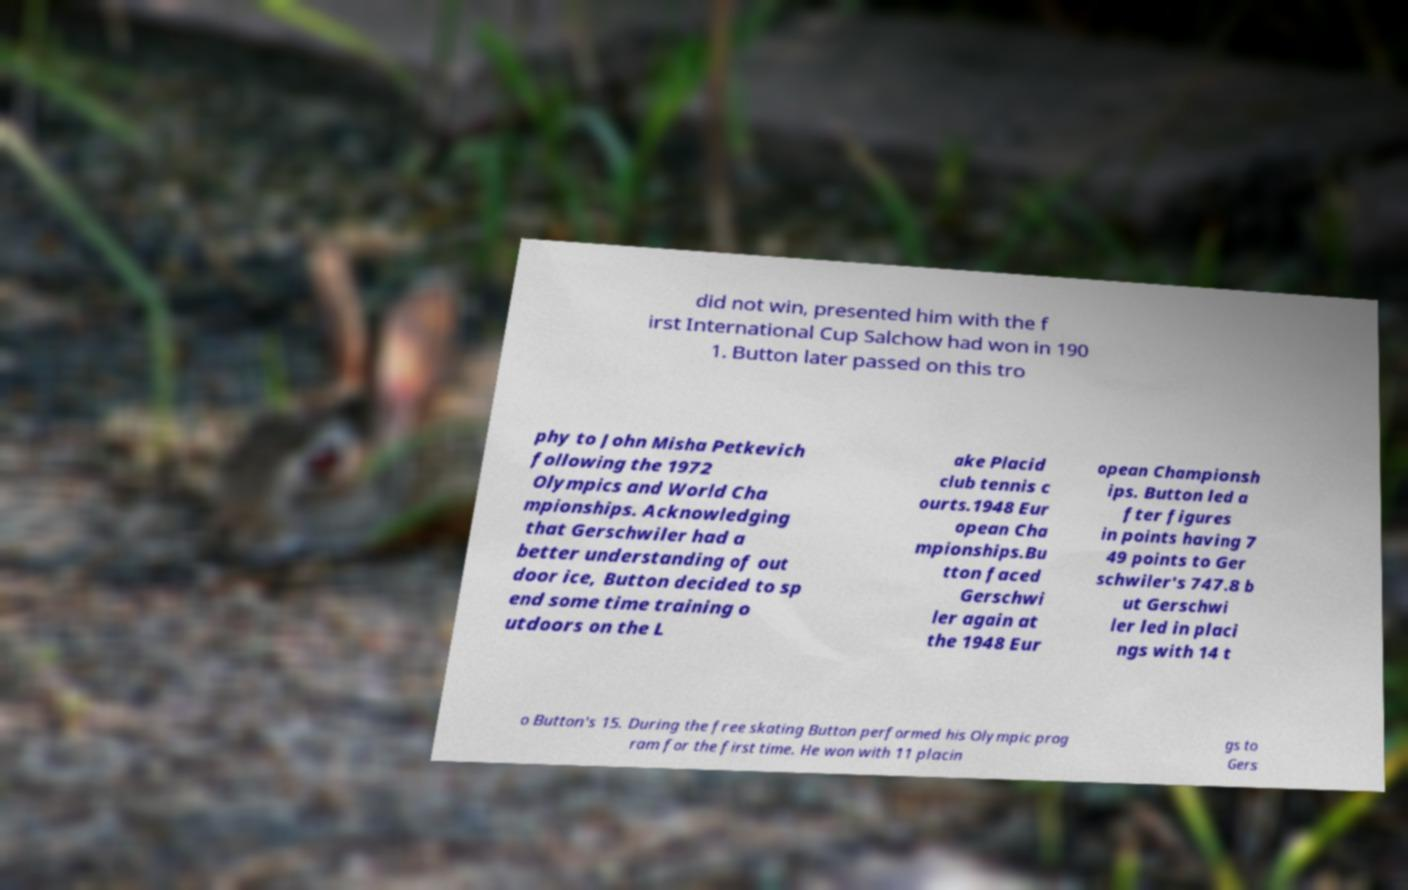There's text embedded in this image that I need extracted. Can you transcribe it verbatim? did not win, presented him with the f irst International Cup Salchow had won in 190 1. Button later passed on this tro phy to John Misha Petkevich following the 1972 Olympics and World Cha mpionships. Acknowledging that Gerschwiler had a better understanding of out door ice, Button decided to sp end some time training o utdoors on the L ake Placid club tennis c ourts.1948 Eur opean Cha mpionships.Bu tton faced Gerschwi ler again at the 1948 Eur opean Championsh ips. Button led a fter figures in points having 7 49 points to Ger schwiler's 747.8 b ut Gerschwi ler led in placi ngs with 14 t o Button's 15. During the free skating Button performed his Olympic prog ram for the first time. He won with 11 placin gs to Gers 